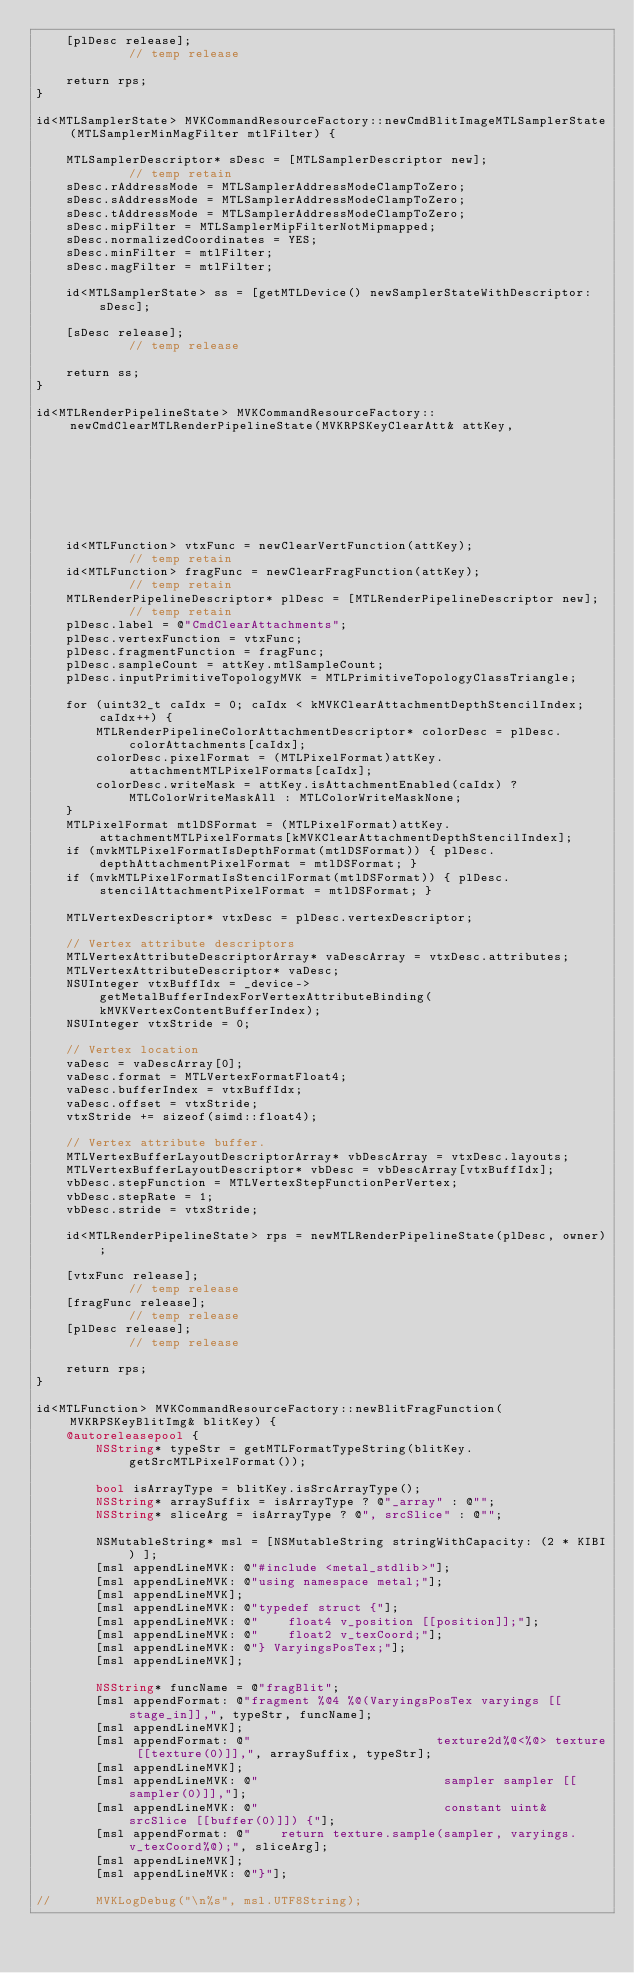<code> <loc_0><loc_0><loc_500><loc_500><_ObjectiveC_>	[plDesc release];															// temp release

	return rps;
}

id<MTLSamplerState> MVKCommandResourceFactory::newCmdBlitImageMTLSamplerState(MTLSamplerMinMagFilter mtlFilter) {

    MTLSamplerDescriptor* sDesc = [MTLSamplerDescriptor new];					// temp retain
    sDesc.rAddressMode = MTLSamplerAddressModeClampToZero;
    sDesc.sAddressMode = MTLSamplerAddressModeClampToZero;
    sDesc.tAddressMode = MTLSamplerAddressModeClampToZero;
    sDesc.mipFilter = MTLSamplerMipFilterNotMipmapped;
    sDesc.normalizedCoordinates = YES;
    sDesc.minFilter = mtlFilter;
    sDesc.magFilter = mtlFilter;

	id<MTLSamplerState> ss = [getMTLDevice() newSamplerStateWithDescriptor: sDesc];

	[sDesc release];															// temp release

	return ss;
}

id<MTLRenderPipelineState> MVKCommandResourceFactory::newCmdClearMTLRenderPipelineState(MVKRPSKeyClearAtt& attKey,
																						MVKVulkanAPIDeviceObject* owner) {
	id<MTLFunction> vtxFunc = newClearVertFunction(attKey);						// temp retain
	id<MTLFunction> fragFunc = newClearFragFunction(attKey);					// temp retain
	MTLRenderPipelineDescriptor* plDesc = [MTLRenderPipelineDescriptor new];	// temp retain
    plDesc.label = @"CmdClearAttachments";
	plDesc.vertexFunction = vtxFunc;
    plDesc.fragmentFunction = fragFunc;
	plDesc.sampleCount = attKey.mtlSampleCount;
	plDesc.inputPrimitiveTopologyMVK = MTLPrimitiveTopologyClassTriangle;

    for (uint32_t caIdx = 0; caIdx < kMVKClearAttachmentDepthStencilIndex; caIdx++) {
        MTLRenderPipelineColorAttachmentDescriptor* colorDesc = plDesc.colorAttachments[caIdx];
        colorDesc.pixelFormat = (MTLPixelFormat)attKey.attachmentMTLPixelFormats[caIdx];
        colorDesc.writeMask = attKey.isAttachmentEnabled(caIdx) ? MTLColorWriteMaskAll : MTLColorWriteMaskNone;
    }
    MTLPixelFormat mtlDSFormat = (MTLPixelFormat)attKey.attachmentMTLPixelFormats[kMVKClearAttachmentDepthStencilIndex];
    if (mvkMTLPixelFormatIsDepthFormat(mtlDSFormat)) { plDesc.depthAttachmentPixelFormat = mtlDSFormat; }
    if (mvkMTLPixelFormatIsStencilFormat(mtlDSFormat)) { plDesc.stencilAttachmentPixelFormat = mtlDSFormat; }

    MTLVertexDescriptor* vtxDesc = plDesc.vertexDescriptor;

    // Vertex attribute descriptors
    MTLVertexAttributeDescriptorArray* vaDescArray = vtxDesc.attributes;
    MTLVertexAttributeDescriptor* vaDesc;
    NSUInteger vtxBuffIdx = _device->getMetalBufferIndexForVertexAttributeBinding(kMVKVertexContentBufferIndex);
    NSUInteger vtxStride = 0;

    // Vertex location
    vaDesc = vaDescArray[0];
    vaDesc.format = MTLVertexFormatFloat4;
    vaDesc.bufferIndex = vtxBuffIdx;
    vaDesc.offset = vtxStride;
    vtxStride += sizeof(simd::float4);

    // Vertex attribute buffer.
    MTLVertexBufferLayoutDescriptorArray* vbDescArray = vtxDesc.layouts;
    MTLVertexBufferLayoutDescriptor* vbDesc = vbDescArray[vtxBuffIdx];
    vbDesc.stepFunction = MTLVertexStepFunctionPerVertex;
    vbDesc.stepRate = 1;
    vbDesc.stride = vtxStride;

	id<MTLRenderPipelineState> rps = newMTLRenderPipelineState(plDesc, owner);

	[vtxFunc release];															// temp release
	[fragFunc release];															// temp release
	[plDesc release];															// temp release

	return rps;
}

id<MTLFunction> MVKCommandResourceFactory::newBlitFragFunction(MVKRPSKeyBlitImg& blitKey) {
	@autoreleasepool {
		NSString* typeStr = getMTLFormatTypeString(blitKey.getSrcMTLPixelFormat());

		bool isArrayType = blitKey.isSrcArrayType();
		NSString* arraySuffix = isArrayType ? @"_array" : @"";
		NSString* sliceArg = isArrayType ? @", srcSlice" : @"";

		NSMutableString* msl = [NSMutableString stringWithCapacity: (2 * KIBI) ];
		[msl appendLineMVK: @"#include <metal_stdlib>"];
		[msl appendLineMVK: @"using namespace metal;"];
		[msl appendLineMVK];
		[msl appendLineMVK: @"typedef struct {"];
		[msl appendLineMVK: @"    float4 v_position [[position]];"];
		[msl appendLineMVK: @"    float2 v_texCoord;"];
		[msl appendLineMVK: @"} VaryingsPosTex;"];
		[msl appendLineMVK];

		NSString* funcName = @"fragBlit";
		[msl appendFormat: @"fragment %@4 %@(VaryingsPosTex varyings [[stage_in]],", typeStr, funcName];
		[msl appendLineMVK];
		[msl appendFormat: @"                         texture2d%@<%@> texture [[texture(0)]],", arraySuffix, typeStr];
		[msl appendLineMVK];
		[msl appendLineMVK: @"                         sampler sampler [[sampler(0)]],"];
		[msl appendLineMVK: @"                         constant uint& srcSlice [[buffer(0)]]) {"];
		[msl appendFormat: @"    return texture.sample(sampler, varyings.v_texCoord%@);", sliceArg];
		[msl appendLineMVK];
		[msl appendLineMVK: @"}"];

//		MVKLogDebug("\n%s", msl.UTF8String);
</code> 